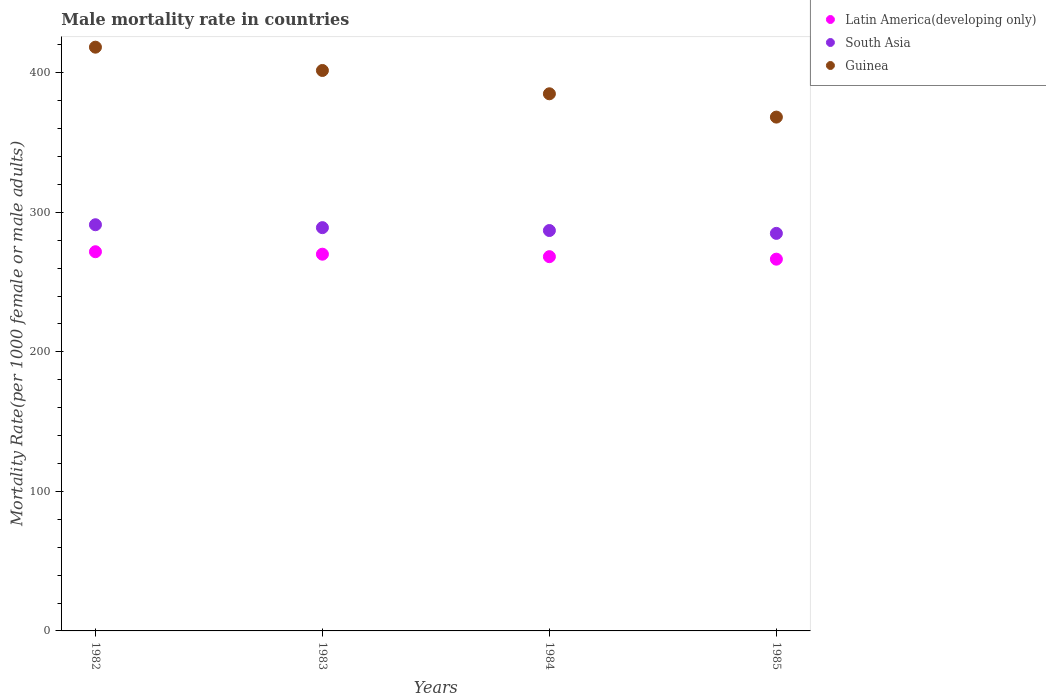How many different coloured dotlines are there?
Make the answer very short. 3. Is the number of dotlines equal to the number of legend labels?
Give a very brief answer. Yes. What is the male mortality rate in South Asia in 1985?
Your response must be concise. 284.89. Across all years, what is the maximum male mortality rate in South Asia?
Ensure brevity in your answer.  291.08. Across all years, what is the minimum male mortality rate in Latin America(developing only)?
Offer a terse response. 266.41. In which year was the male mortality rate in Guinea maximum?
Keep it short and to the point. 1982. In which year was the male mortality rate in Latin America(developing only) minimum?
Your response must be concise. 1985. What is the total male mortality rate in South Asia in the graph?
Offer a very short reply. 1151.9. What is the difference between the male mortality rate in Latin America(developing only) in 1982 and that in 1984?
Offer a terse response. 3.53. What is the difference between the male mortality rate in Guinea in 1983 and the male mortality rate in Latin America(developing only) in 1982?
Make the answer very short. 129.89. What is the average male mortality rate in Latin America(developing only) per year?
Provide a succinct answer. 269.08. In the year 1985, what is the difference between the male mortality rate in South Asia and male mortality rate in Guinea?
Give a very brief answer. -83.32. In how many years, is the male mortality rate in South Asia greater than 140?
Offer a terse response. 4. What is the ratio of the male mortality rate in Latin America(developing only) in 1982 to that in 1983?
Make the answer very short. 1.01. Is the difference between the male mortality rate in South Asia in 1983 and 1985 greater than the difference between the male mortality rate in Guinea in 1983 and 1985?
Provide a succinct answer. No. What is the difference between the highest and the second highest male mortality rate in Latin America(developing only)?
Give a very brief answer. 1.76. What is the difference between the highest and the lowest male mortality rate in South Asia?
Your answer should be very brief. 6.19. Does the male mortality rate in South Asia monotonically increase over the years?
Offer a very short reply. No. Is the male mortality rate in Latin America(developing only) strictly greater than the male mortality rate in Guinea over the years?
Your answer should be compact. No. How many dotlines are there?
Offer a terse response. 3. Are the values on the major ticks of Y-axis written in scientific E-notation?
Keep it short and to the point. No. Does the graph contain grids?
Provide a succinct answer. No. Where does the legend appear in the graph?
Provide a succinct answer. Top right. How many legend labels are there?
Keep it short and to the point. 3. What is the title of the graph?
Your answer should be very brief. Male mortality rate in countries. Does "Brazil" appear as one of the legend labels in the graph?
Keep it short and to the point. No. What is the label or title of the Y-axis?
Your response must be concise. Mortality Rate(per 1000 female or male adults). What is the Mortality Rate(per 1000 female or male adults) of Latin America(developing only) in 1982?
Your answer should be very brief. 271.73. What is the Mortality Rate(per 1000 female or male adults) of South Asia in 1982?
Provide a short and direct response. 291.08. What is the Mortality Rate(per 1000 female or male adults) of Guinea in 1982?
Provide a succinct answer. 418.32. What is the Mortality Rate(per 1000 female or male adults) of Latin America(developing only) in 1983?
Give a very brief answer. 269.97. What is the Mortality Rate(per 1000 female or male adults) in South Asia in 1983?
Keep it short and to the point. 289. What is the Mortality Rate(per 1000 female or male adults) in Guinea in 1983?
Your answer should be compact. 401.62. What is the Mortality Rate(per 1000 female or male adults) of Latin America(developing only) in 1984?
Give a very brief answer. 268.2. What is the Mortality Rate(per 1000 female or male adults) in South Asia in 1984?
Your response must be concise. 286.93. What is the Mortality Rate(per 1000 female or male adults) of Guinea in 1984?
Keep it short and to the point. 384.92. What is the Mortality Rate(per 1000 female or male adults) of Latin America(developing only) in 1985?
Keep it short and to the point. 266.41. What is the Mortality Rate(per 1000 female or male adults) in South Asia in 1985?
Your answer should be compact. 284.89. What is the Mortality Rate(per 1000 female or male adults) in Guinea in 1985?
Your answer should be very brief. 368.22. Across all years, what is the maximum Mortality Rate(per 1000 female or male adults) in Latin America(developing only)?
Provide a short and direct response. 271.73. Across all years, what is the maximum Mortality Rate(per 1000 female or male adults) of South Asia?
Offer a terse response. 291.08. Across all years, what is the maximum Mortality Rate(per 1000 female or male adults) in Guinea?
Your response must be concise. 418.32. Across all years, what is the minimum Mortality Rate(per 1000 female or male adults) in Latin America(developing only)?
Offer a terse response. 266.41. Across all years, what is the minimum Mortality Rate(per 1000 female or male adults) in South Asia?
Offer a terse response. 284.89. Across all years, what is the minimum Mortality Rate(per 1000 female or male adults) of Guinea?
Your answer should be compact. 368.22. What is the total Mortality Rate(per 1000 female or male adults) in Latin America(developing only) in the graph?
Provide a succinct answer. 1076.32. What is the total Mortality Rate(per 1000 female or male adults) in South Asia in the graph?
Your answer should be very brief. 1151.9. What is the total Mortality Rate(per 1000 female or male adults) in Guinea in the graph?
Your answer should be compact. 1573.08. What is the difference between the Mortality Rate(per 1000 female or male adults) of Latin America(developing only) in 1982 and that in 1983?
Offer a very short reply. 1.76. What is the difference between the Mortality Rate(per 1000 female or male adults) of South Asia in 1982 and that in 1983?
Make the answer very short. 2.08. What is the difference between the Mortality Rate(per 1000 female or male adults) in Guinea in 1982 and that in 1983?
Provide a succinct answer. 16.7. What is the difference between the Mortality Rate(per 1000 female or male adults) of Latin America(developing only) in 1982 and that in 1984?
Offer a terse response. 3.53. What is the difference between the Mortality Rate(per 1000 female or male adults) of South Asia in 1982 and that in 1984?
Ensure brevity in your answer.  4.15. What is the difference between the Mortality Rate(per 1000 female or male adults) in Guinea in 1982 and that in 1984?
Offer a terse response. 33.41. What is the difference between the Mortality Rate(per 1000 female or male adults) of Latin America(developing only) in 1982 and that in 1985?
Ensure brevity in your answer.  5.32. What is the difference between the Mortality Rate(per 1000 female or male adults) of South Asia in 1982 and that in 1985?
Your answer should be compact. 6.19. What is the difference between the Mortality Rate(per 1000 female or male adults) in Guinea in 1982 and that in 1985?
Provide a short and direct response. 50.11. What is the difference between the Mortality Rate(per 1000 female or male adults) in Latin America(developing only) in 1983 and that in 1984?
Your response must be concise. 1.77. What is the difference between the Mortality Rate(per 1000 female or male adults) in South Asia in 1983 and that in 1984?
Offer a terse response. 2.06. What is the difference between the Mortality Rate(per 1000 female or male adults) in Guinea in 1983 and that in 1984?
Keep it short and to the point. 16.7. What is the difference between the Mortality Rate(per 1000 female or male adults) of Latin America(developing only) in 1983 and that in 1985?
Offer a terse response. 3.56. What is the difference between the Mortality Rate(per 1000 female or male adults) in South Asia in 1983 and that in 1985?
Your response must be concise. 4.1. What is the difference between the Mortality Rate(per 1000 female or male adults) in Guinea in 1983 and that in 1985?
Ensure brevity in your answer.  33.41. What is the difference between the Mortality Rate(per 1000 female or male adults) in Latin America(developing only) in 1984 and that in 1985?
Your answer should be compact. 1.79. What is the difference between the Mortality Rate(per 1000 female or male adults) in South Asia in 1984 and that in 1985?
Offer a terse response. 2.04. What is the difference between the Mortality Rate(per 1000 female or male adults) in Guinea in 1984 and that in 1985?
Give a very brief answer. 16.7. What is the difference between the Mortality Rate(per 1000 female or male adults) of Latin America(developing only) in 1982 and the Mortality Rate(per 1000 female or male adults) of South Asia in 1983?
Give a very brief answer. -17.26. What is the difference between the Mortality Rate(per 1000 female or male adults) in Latin America(developing only) in 1982 and the Mortality Rate(per 1000 female or male adults) in Guinea in 1983?
Keep it short and to the point. -129.89. What is the difference between the Mortality Rate(per 1000 female or male adults) in South Asia in 1982 and the Mortality Rate(per 1000 female or male adults) in Guinea in 1983?
Ensure brevity in your answer.  -110.54. What is the difference between the Mortality Rate(per 1000 female or male adults) of Latin America(developing only) in 1982 and the Mortality Rate(per 1000 female or male adults) of South Asia in 1984?
Give a very brief answer. -15.2. What is the difference between the Mortality Rate(per 1000 female or male adults) in Latin America(developing only) in 1982 and the Mortality Rate(per 1000 female or male adults) in Guinea in 1984?
Your answer should be very brief. -113.19. What is the difference between the Mortality Rate(per 1000 female or male adults) of South Asia in 1982 and the Mortality Rate(per 1000 female or male adults) of Guinea in 1984?
Give a very brief answer. -93.84. What is the difference between the Mortality Rate(per 1000 female or male adults) in Latin America(developing only) in 1982 and the Mortality Rate(per 1000 female or male adults) in South Asia in 1985?
Make the answer very short. -13.16. What is the difference between the Mortality Rate(per 1000 female or male adults) of Latin America(developing only) in 1982 and the Mortality Rate(per 1000 female or male adults) of Guinea in 1985?
Your response must be concise. -96.48. What is the difference between the Mortality Rate(per 1000 female or male adults) of South Asia in 1982 and the Mortality Rate(per 1000 female or male adults) of Guinea in 1985?
Offer a terse response. -77.14. What is the difference between the Mortality Rate(per 1000 female or male adults) of Latin America(developing only) in 1983 and the Mortality Rate(per 1000 female or male adults) of South Asia in 1984?
Make the answer very short. -16.96. What is the difference between the Mortality Rate(per 1000 female or male adults) of Latin America(developing only) in 1983 and the Mortality Rate(per 1000 female or male adults) of Guinea in 1984?
Keep it short and to the point. -114.95. What is the difference between the Mortality Rate(per 1000 female or male adults) of South Asia in 1983 and the Mortality Rate(per 1000 female or male adults) of Guinea in 1984?
Keep it short and to the point. -95.92. What is the difference between the Mortality Rate(per 1000 female or male adults) in Latin America(developing only) in 1983 and the Mortality Rate(per 1000 female or male adults) in South Asia in 1985?
Give a very brief answer. -14.92. What is the difference between the Mortality Rate(per 1000 female or male adults) in Latin America(developing only) in 1983 and the Mortality Rate(per 1000 female or male adults) in Guinea in 1985?
Ensure brevity in your answer.  -98.24. What is the difference between the Mortality Rate(per 1000 female or male adults) in South Asia in 1983 and the Mortality Rate(per 1000 female or male adults) in Guinea in 1985?
Give a very brief answer. -79.22. What is the difference between the Mortality Rate(per 1000 female or male adults) of Latin America(developing only) in 1984 and the Mortality Rate(per 1000 female or male adults) of South Asia in 1985?
Provide a short and direct response. -16.69. What is the difference between the Mortality Rate(per 1000 female or male adults) in Latin America(developing only) in 1984 and the Mortality Rate(per 1000 female or male adults) in Guinea in 1985?
Your answer should be compact. -100.02. What is the difference between the Mortality Rate(per 1000 female or male adults) of South Asia in 1984 and the Mortality Rate(per 1000 female or male adults) of Guinea in 1985?
Offer a very short reply. -81.28. What is the average Mortality Rate(per 1000 female or male adults) of Latin America(developing only) per year?
Give a very brief answer. 269.08. What is the average Mortality Rate(per 1000 female or male adults) in South Asia per year?
Give a very brief answer. 287.97. What is the average Mortality Rate(per 1000 female or male adults) in Guinea per year?
Offer a terse response. 393.27. In the year 1982, what is the difference between the Mortality Rate(per 1000 female or male adults) in Latin America(developing only) and Mortality Rate(per 1000 female or male adults) in South Asia?
Offer a terse response. -19.34. In the year 1982, what is the difference between the Mortality Rate(per 1000 female or male adults) of Latin America(developing only) and Mortality Rate(per 1000 female or male adults) of Guinea?
Make the answer very short. -146.59. In the year 1982, what is the difference between the Mortality Rate(per 1000 female or male adults) in South Asia and Mortality Rate(per 1000 female or male adults) in Guinea?
Give a very brief answer. -127.25. In the year 1983, what is the difference between the Mortality Rate(per 1000 female or male adults) of Latin America(developing only) and Mortality Rate(per 1000 female or male adults) of South Asia?
Your answer should be compact. -19.02. In the year 1983, what is the difference between the Mortality Rate(per 1000 female or male adults) in Latin America(developing only) and Mortality Rate(per 1000 female or male adults) in Guinea?
Give a very brief answer. -131.65. In the year 1983, what is the difference between the Mortality Rate(per 1000 female or male adults) of South Asia and Mortality Rate(per 1000 female or male adults) of Guinea?
Provide a short and direct response. -112.63. In the year 1984, what is the difference between the Mortality Rate(per 1000 female or male adults) in Latin America(developing only) and Mortality Rate(per 1000 female or male adults) in South Asia?
Keep it short and to the point. -18.73. In the year 1984, what is the difference between the Mortality Rate(per 1000 female or male adults) in Latin America(developing only) and Mortality Rate(per 1000 female or male adults) in Guinea?
Make the answer very short. -116.72. In the year 1984, what is the difference between the Mortality Rate(per 1000 female or male adults) of South Asia and Mortality Rate(per 1000 female or male adults) of Guinea?
Make the answer very short. -97.99. In the year 1985, what is the difference between the Mortality Rate(per 1000 female or male adults) in Latin America(developing only) and Mortality Rate(per 1000 female or male adults) in South Asia?
Offer a very short reply. -18.48. In the year 1985, what is the difference between the Mortality Rate(per 1000 female or male adults) in Latin America(developing only) and Mortality Rate(per 1000 female or male adults) in Guinea?
Provide a succinct answer. -101.81. In the year 1985, what is the difference between the Mortality Rate(per 1000 female or male adults) of South Asia and Mortality Rate(per 1000 female or male adults) of Guinea?
Give a very brief answer. -83.32. What is the ratio of the Mortality Rate(per 1000 female or male adults) of South Asia in 1982 to that in 1983?
Your answer should be compact. 1.01. What is the ratio of the Mortality Rate(per 1000 female or male adults) in Guinea in 1982 to that in 1983?
Provide a short and direct response. 1.04. What is the ratio of the Mortality Rate(per 1000 female or male adults) of Latin America(developing only) in 1982 to that in 1984?
Provide a succinct answer. 1.01. What is the ratio of the Mortality Rate(per 1000 female or male adults) of South Asia in 1982 to that in 1984?
Provide a short and direct response. 1.01. What is the ratio of the Mortality Rate(per 1000 female or male adults) of Guinea in 1982 to that in 1984?
Offer a terse response. 1.09. What is the ratio of the Mortality Rate(per 1000 female or male adults) in Latin America(developing only) in 1982 to that in 1985?
Keep it short and to the point. 1.02. What is the ratio of the Mortality Rate(per 1000 female or male adults) of South Asia in 1982 to that in 1985?
Give a very brief answer. 1.02. What is the ratio of the Mortality Rate(per 1000 female or male adults) in Guinea in 1982 to that in 1985?
Provide a short and direct response. 1.14. What is the ratio of the Mortality Rate(per 1000 female or male adults) of Latin America(developing only) in 1983 to that in 1984?
Your answer should be very brief. 1.01. What is the ratio of the Mortality Rate(per 1000 female or male adults) in South Asia in 1983 to that in 1984?
Give a very brief answer. 1.01. What is the ratio of the Mortality Rate(per 1000 female or male adults) in Guinea in 1983 to that in 1984?
Provide a short and direct response. 1.04. What is the ratio of the Mortality Rate(per 1000 female or male adults) in Latin America(developing only) in 1983 to that in 1985?
Ensure brevity in your answer.  1.01. What is the ratio of the Mortality Rate(per 1000 female or male adults) of South Asia in 1983 to that in 1985?
Make the answer very short. 1.01. What is the ratio of the Mortality Rate(per 1000 female or male adults) in Guinea in 1983 to that in 1985?
Offer a terse response. 1.09. What is the ratio of the Mortality Rate(per 1000 female or male adults) of Latin America(developing only) in 1984 to that in 1985?
Offer a terse response. 1.01. What is the ratio of the Mortality Rate(per 1000 female or male adults) in South Asia in 1984 to that in 1985?
Keep it short and to the point. 1.01. What is the ratio of the Mortality Rate(per 1000 female or male adults) of Guinea in 1984 to that in 1985?
Your answer should be very brief. 1.05. What is the difference between the highest and the second highest Mortality Rate(per 1000 female or male adults) in Latin America(developing only)?
Provide a succinct answer. 1.76. What is the difference between the highest and the second highest Mortality Rate(per 1000 female or male adults) in South Asia?
Keep it short and to the point. 2.08. What is the difference between the highest and the second highest Mortality Rate(per 1000 female or male adults) in Guinea?
Your answer should be very brief. 16.7. What is the difference between the highest and the lowest Mortality Rate(per 1000 female or male adults) in Latin America(developing only)?
Your response must be concise. 5.32. What is the difference between the highest and the lowest Mortality Rate(per 1000 female or male adults) of South Asia?
Give a very brief answer. 6.19. What is the difference between the highest and the lowest Mortality Rate(per 1000 female or male adults) of Guinea?
Provide a succinct answer. 50.11. 